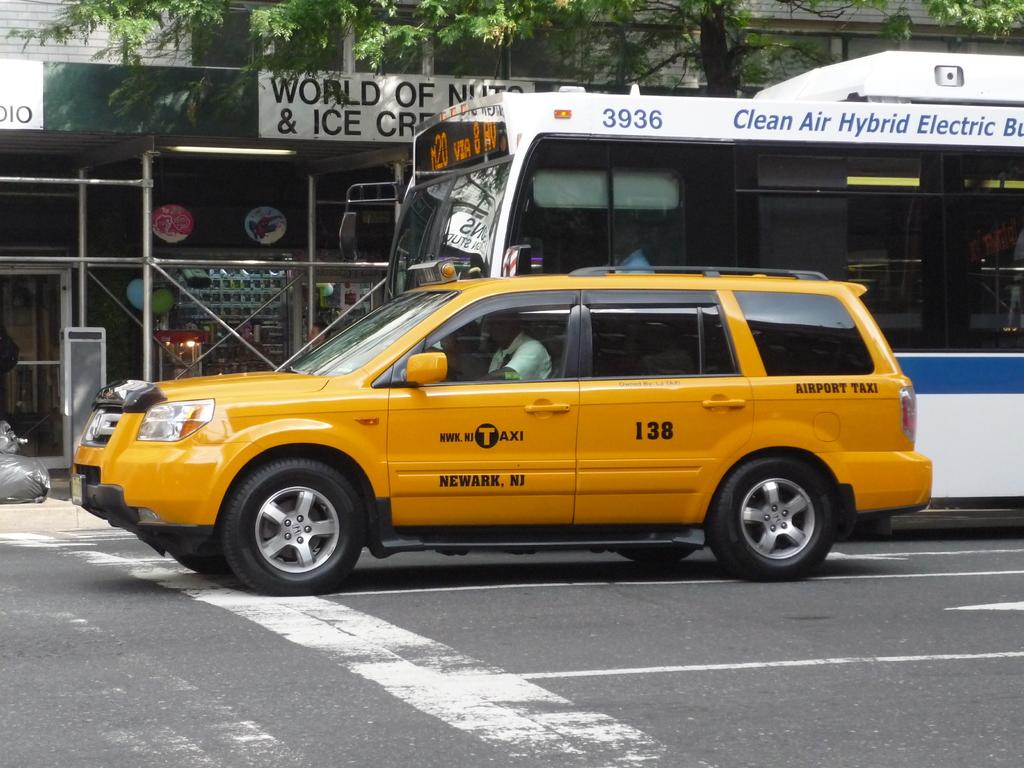<image>
Relay a brief, clear account of the picture shown. A taxi is marked Newark, NJ on the side. 